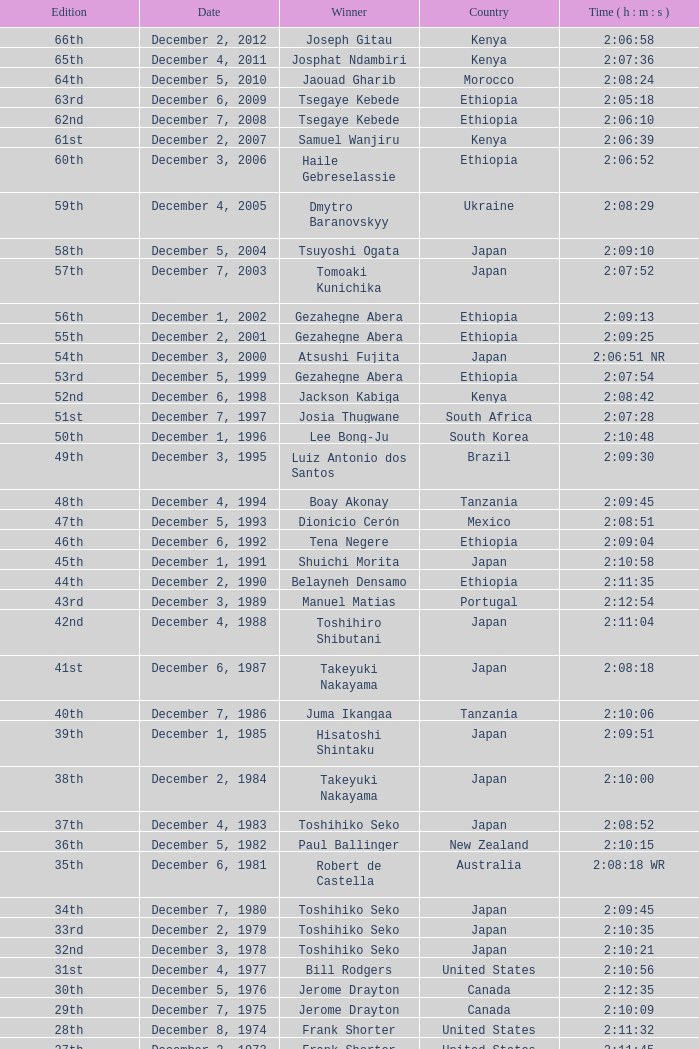On which date did lee bong-ju successfully complete a race with a winning time of 2:10:48? December 1, 1996. 